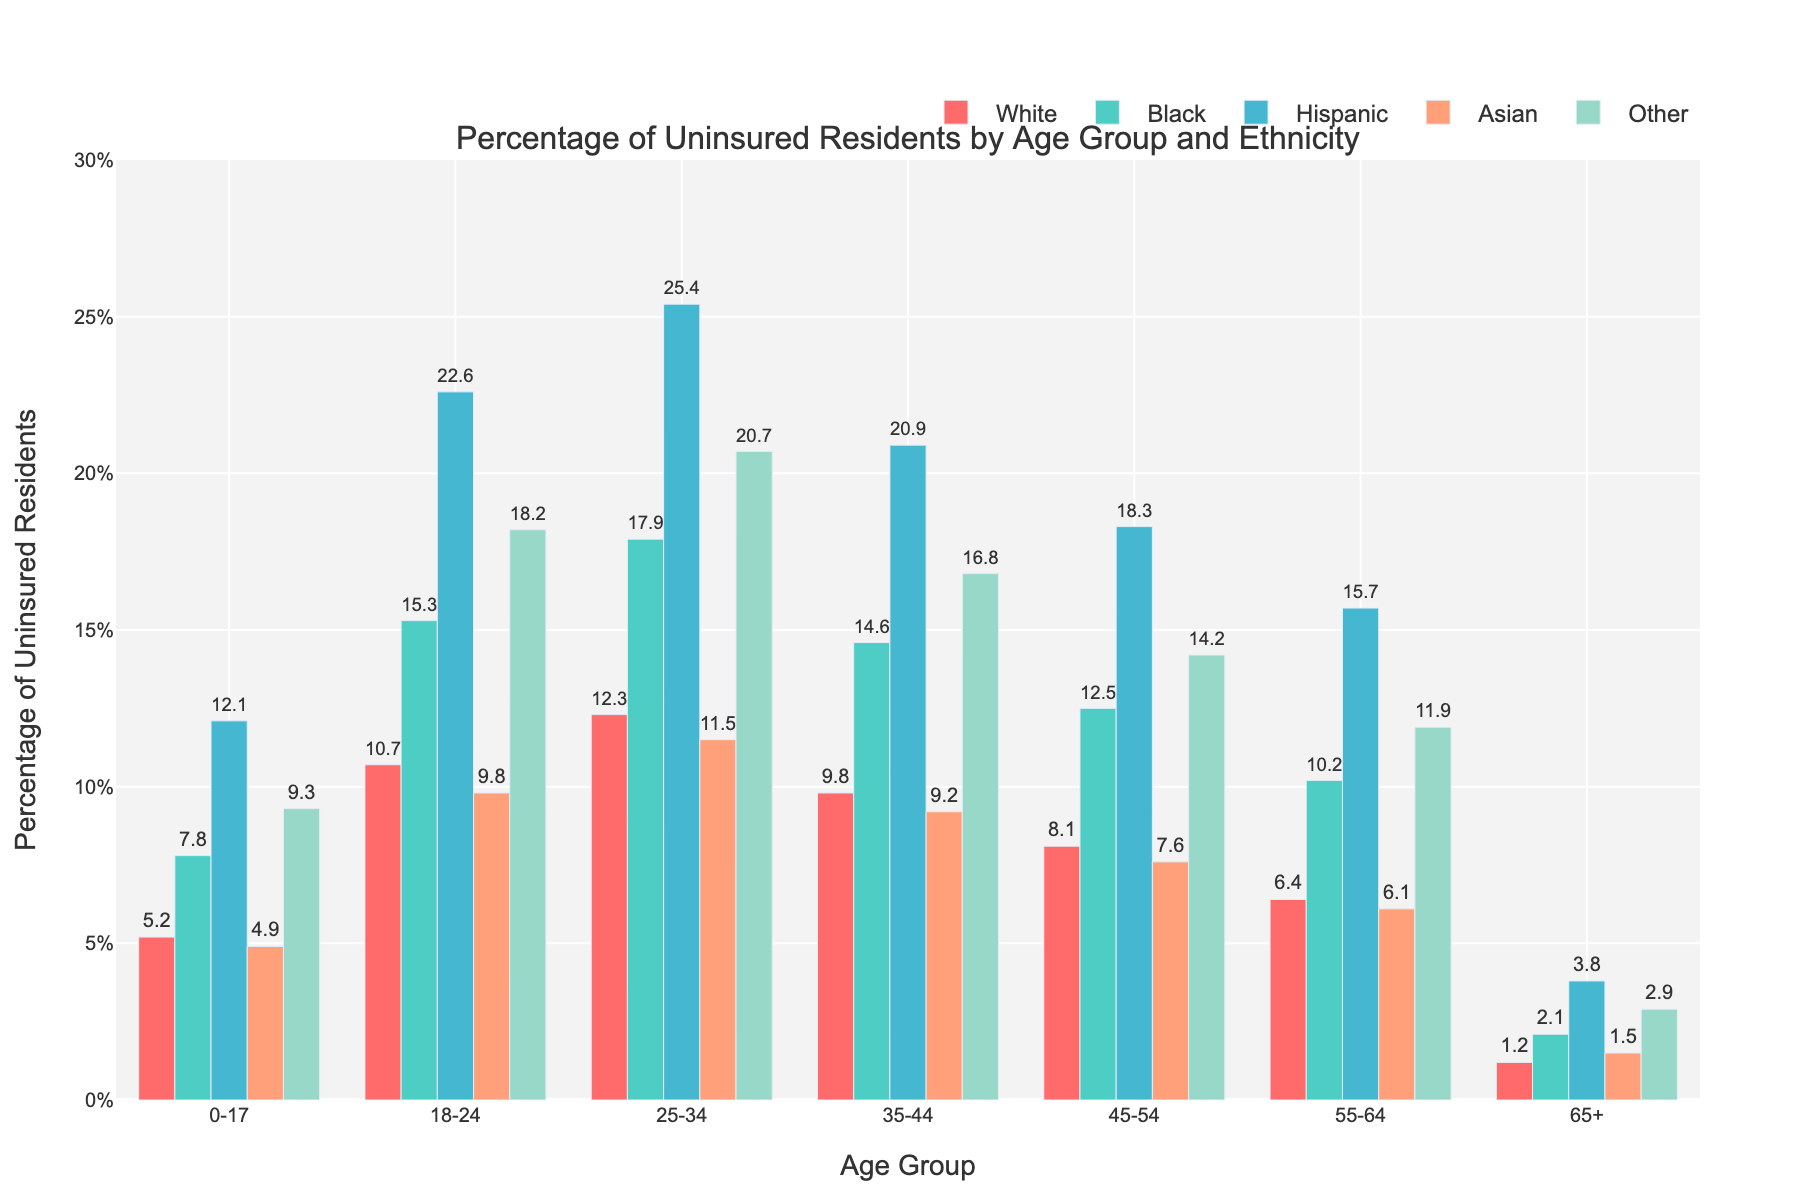Which age group has the highest percentage of uninsured Hispanic residents? By looking at the figure, identify the bar that reaches the highest point among Hispanic residents for all age groups. The bar for age group 25-34 is the tallest for Hispanics.
Answer: 25-34 Which ethnicity has the lowest percentage of uninsured residents in the 0-17 age group? Observe the heights of the bars for the 0-17 age group and determine which bar is the shortest. The bar for Asian residents is the shortest.
Answer: Asian What is the difference in the percentage of uninsured residents between White and Black individuals in the 55-64 age group? Look at the bars for White and Black residents in the 55-64 age group and subtract the value for White from the value for Black. 10.2% (Black) - 6.4% (White) = 3.8%
Answer: 3.8% Which age group has the least variation in the percentage of uninsured residents across different ethnicities? Examine the spread of bar heights for each age group: the 65+ age group shows the least variation because the bars are fairly close in height.
Answer: 65+ How much higher is the percentage of uninsured Hispanic residents compared to Black residents in the 18-24 age group? Compare the heights of the corresponding bars: 22.6% (Hispanic) - 15.3% (Black) = 7.3%.
Answer: 7.3% What is the average percentage of uninsured residents for the 35-44 age group? Sum the percentages of uninsured residents for all ethnicities in the 35-44 age group and divide by the number of ethnicities: (9.8 + 14.6 + 20.9 + 9.2 + 16.8) / 5 = 14.26%
Answer: 14.26% Which ethnic group shows the most drastic reduction in the percentage of uninsured residents from the 18-24 age group to the 65+ age group? Subtract the percentage of uninsured for each ethnic group in the 65+ age group from their corresponding value in the 18-24 group and find the maximum difference: Hispanic residents show the highest reduction, 22.6% - 3.8% = 18.8%.
Answer: Hispanic Which ethnicity consistently has the second highest percentage of uninsured residents across all age groups? Visually compare and rank the heights of the bars within each age group. The Black ethnicity appears consistently second highest in all but the youngest category.
Answer: Black Which two ethnicities have the closest percentages of uninsured residents in the 35-44 age group? Compare the heights of the bars and look for the bars that are closest in height. White and Asian residents have close percentages: 9.8% and 9.2% respectively, with a difference of only 0.6%.
Answer: White and Asian 